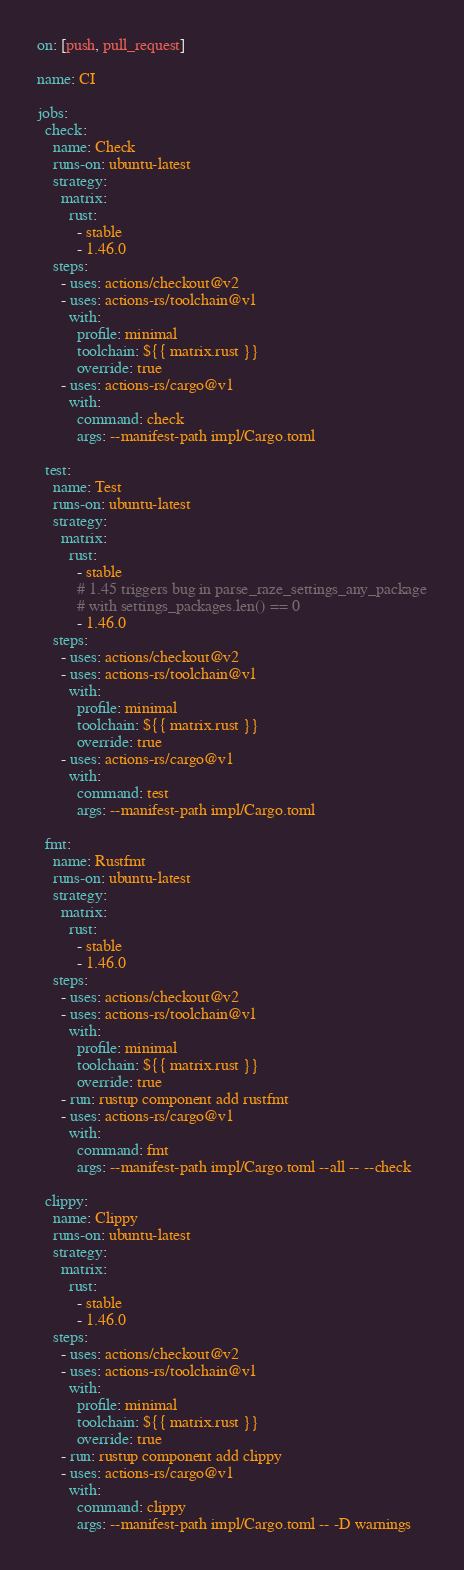<code> <loc_0><loc_0><loc_500><loc_500><_YAML_>on: [push, pull_request]

name: CI

jobs:
  check:
    name: Check
    runs-on: ubuntu-latest
    strategy:
      matrix:
        rust:
          - stable
          - 1.46.0
    steps:
      - uses: actions/checkout@v2
      - uses: actions-rs/toolchain@v1
        with:
          profile: minimal
          toolchain: ${{ matrix.rust }}
          override: true
      - uses: actions-rs/cargo@v1
        with:
          command: check
          args: --manifest-path impl/Cargo.toml

  test:
    name: Test
    runs-on: ubuntu-latest
    strategy:
      matrix:
        rust:
          - stable
          # 1.45 triggers bug in parse_raze_settings_any_package
          # with settings_packages.len() == 0
          - 1.46.0
    steps:
      - uses: actions/checkout@v2
      - uses: actions-rs/toolchain@v1
        with:
          profile: minimal
          toolchain: ${{ matrix.rust }}
          override: true
      - uses: actions-rs/cargo@v1
        with:
          command: test
          args: --manifest-path impl/Cargo.toml

  fmt:
    name: Rustfmt
    runs-on: ubuntu-latest
    strategy:
      matrix:
        rust:
          - stable
          - 1.46.0
    steps:
      - uses: actions/checkout@v2
      - uses: actions-rs/toolchain@v1
        with:
          profile: minimal
          toolchain: ${{ matrix.rust }}
          override: true
      - run: rustup component add rustfmt
      - uses: actions-rs/cargo@v1
        with:
          command: fmt
          args: --manifest-path impl/Cargo.toml --all -- --check

  clippy:
    name: Clippy
    runs-on: ubuntu-latest
    strategy:
      matrix:
        rust:
          - stable
          - 1.46.0
    steps:
      - uses: actions/checkout@v2
      - uses: actions-rs/toolchain@v1
        with:
          profile: minimal
          toolchain: ${{ matrix.rust }}
          override: true
      - run: rustup component add clippy
      - uses: actions-rs/cargo@v1
        with:
          command: clippy
          args: --manifest-path impl/Cargo.toml -- -D warnings
</code> 